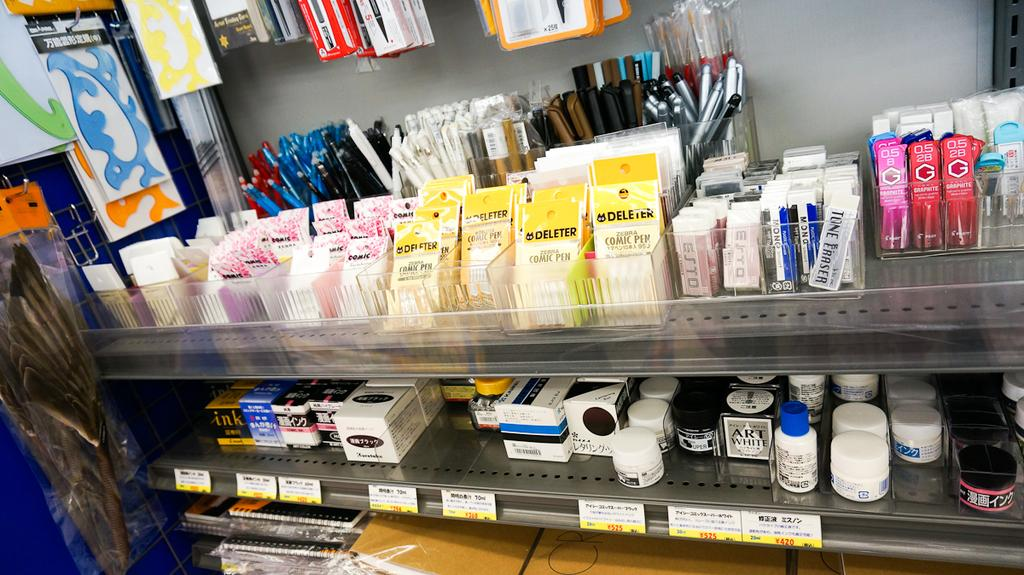<image>
Give a short and clear explanation of the subsequent image. Deleter comic pens and other office supplies are for sale in a store. 